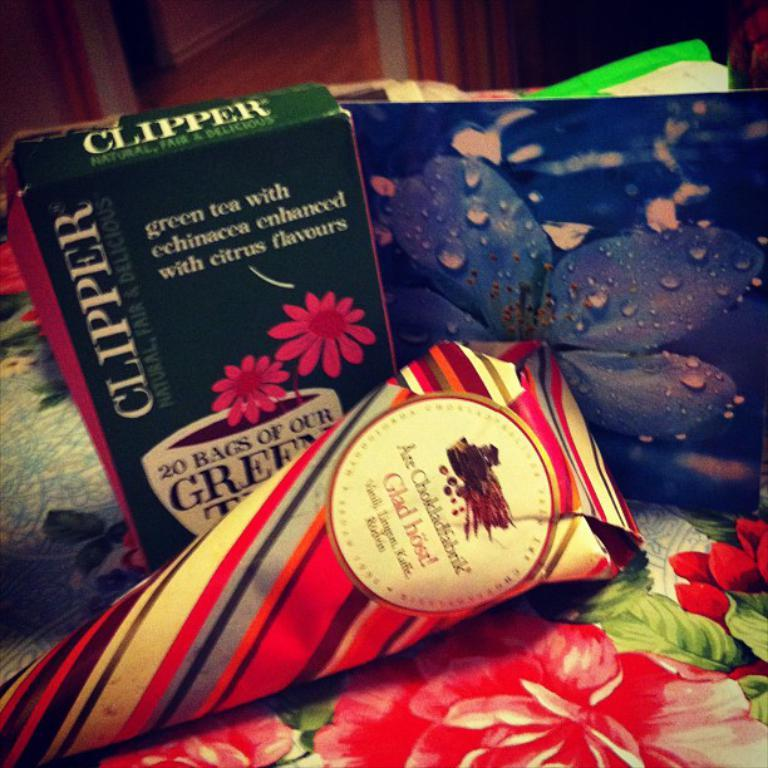<image>
Write a terse but informative summary of the picture. A box of Clipper green tea sits among differently patterned papers. 